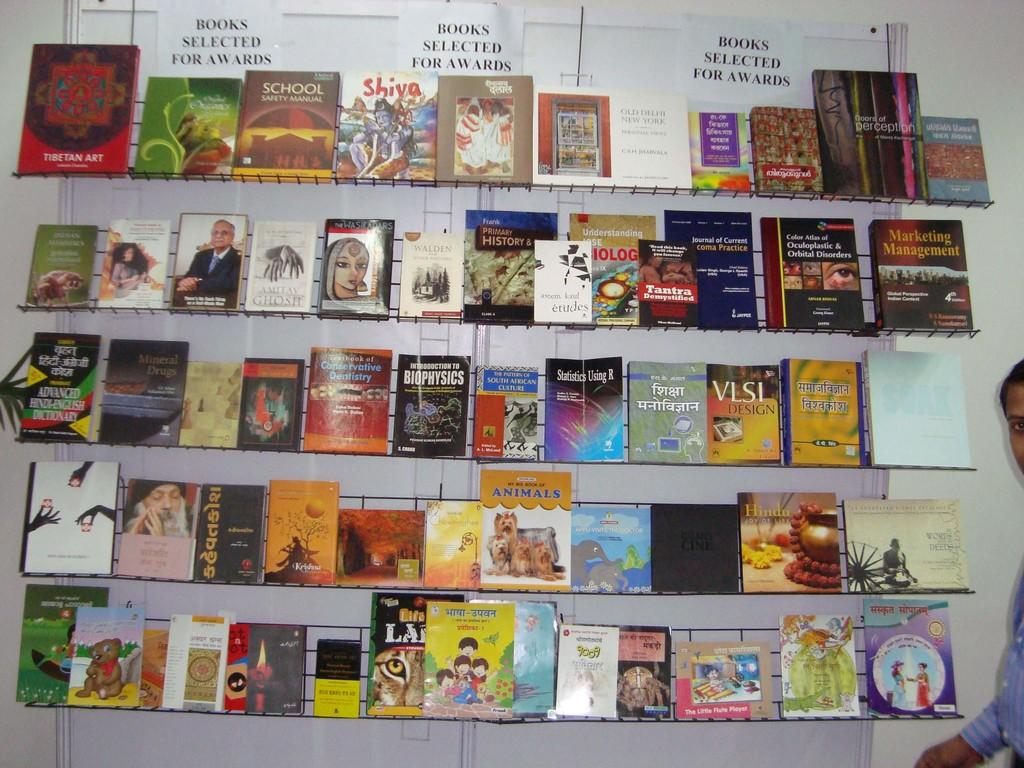What can be seen on the shelves in the image? There are many books in the shelves. Where is the person located in the image? The person is standing on the right side of the image. What color is the wall at the back of the image? The wall at the back of the image is white. What type of cork can be seen on the wall in the image? There is no cork present on the wall in the image; it is a white wall. How does the butter contribute to the image? There is no butter present in the image. 